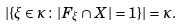Convert formula to latex. <formula><loc_0><loc_0><loc_500><loc_500>| \{ \xi \in \kappa \colon | F _ { \xi } \cap X | = 1 \} | = \kappa .</formula> 